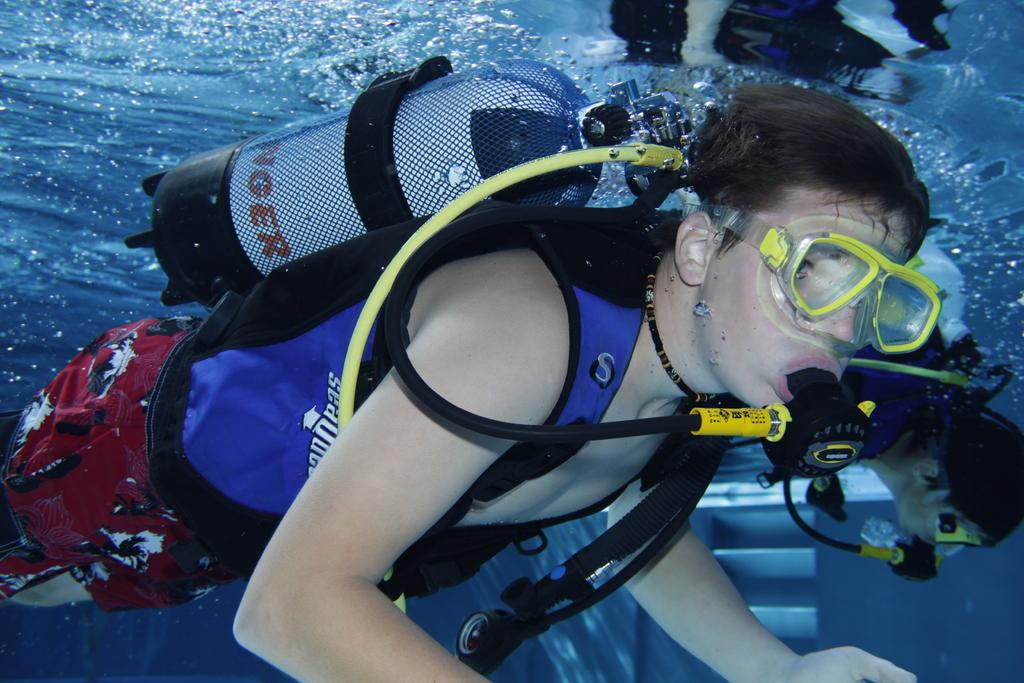What are the people in the image doing? The people in the image are in the water. Can you describe any specific items that one of the people is wearing? One person is wearing goggles. What type of object can be seen in the image that is typically used for transporting water or gas? There is a pipe visible in the image. What safety equipment is present in the image? There is an oxygen cylinder in the image. What country is the image taken in? The provided facts do not mention the country where the image was taken. What type of work are the people in the image doing? The provided facts do not mention any specific work or activity that the people in the image are engaged in. Is there any quicksand present in the image? There is no mention of quicksand in the provided facts, and it is not visible in the image. 